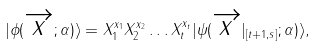Convert formula to latex. <formula><loc_0><loc_0><loc_500><loc_500>| { \phi } ( \overrightarrow { x } ; \alpha ) \rangle = { X } ^ { x _ { 1 } } _ { 1 } { X } ^ { x _ { 2 } } _ { 2 } \dots { X } ^ { x _ { t } } _ { t } | { \psi } ( \overrightarrow { x } | _ { [ t + 1 , s ] } ; \alpha ) \rangle ,</formula> 